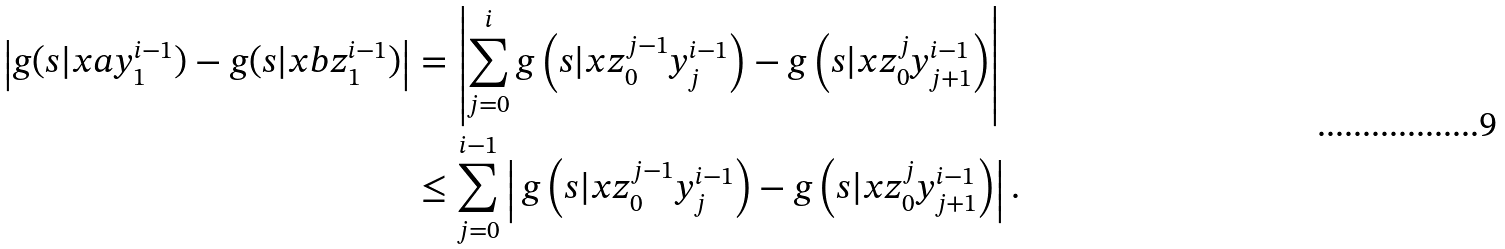<formula> <loc_0><loc_0><loc_500><loc_500>\left | g ( s | x a y _ { 1 } ^ { i - 1 } ) - g ( s | x b z _ { 1 } ^ { i - 1 } ) \right | & = \left | \sum _ { j = 0 } ^ { i } g \left ( s | x z _ { 0 } ^ { j - 1 } y _ { j } ^ { i - 1 } \right ) - g \left ( s | x z _ { 0 } ^ { j } y _ { j + 1 } ^ { i - 1 } \right ) \right | \\ & \leq \sum _ { j = 0 } ^ { i - 1 } \left | \, g \left ( s | x z _ { 0 } ^ { j - 1 } y _ { j } ^ { i - 1 } \right ) - g \left ( s | x z _ { 0 } ^ { j } y _ { j + 1 } ^ { i - 1 } \right ) \right | .</formula> 